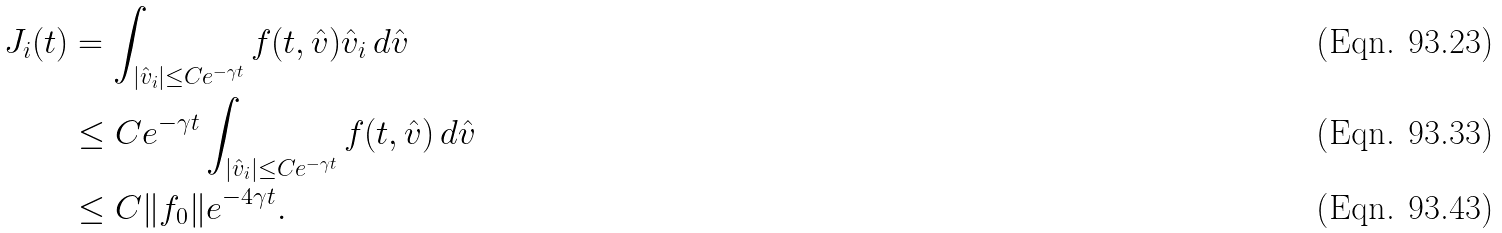<formula> <loc_0><loc_0><loc_500><loc_500>J _ { i } ( t ) & = \int _ { | \hat { v } _ { i } | \leq C e ^ { - \gamma t } } f ( t , \hat { v } ) \hat { v } _ { i } \, d \hat { v } \\ & \leq C e ^ { - \gamma t } \int _ { | \hat { v } _ { i } | \leq C e ^ { - \gamma t } } f ( t , \hat { v } ) \, d \hat { v } \\ & \leq C \| f _ { 0 } \| e ^ { - 4 \gamma t } .</formula> 